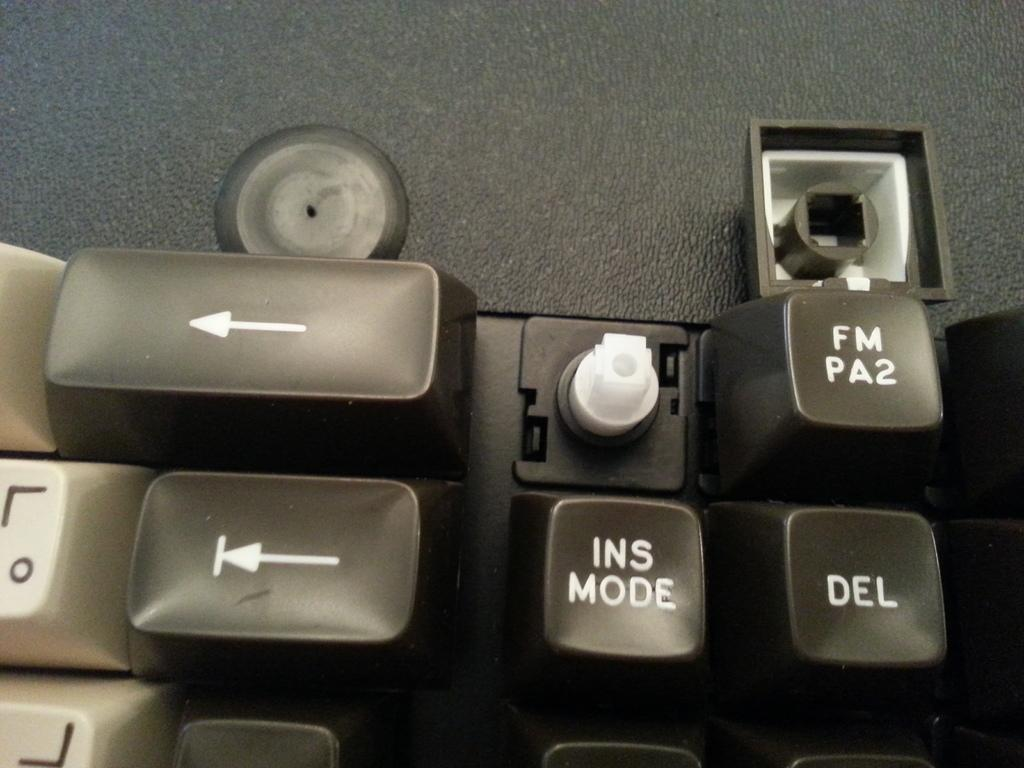<image>
Write a terse but informative summary of the picture. Keyboard keys with a key that says INS MODE 